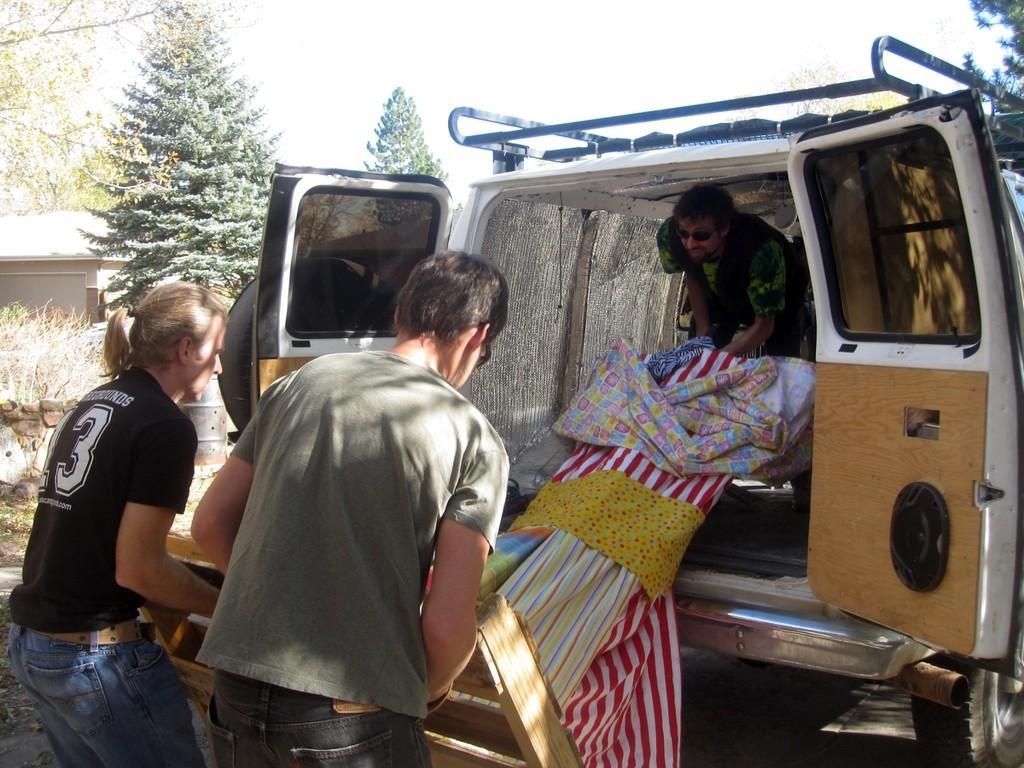Could you give a brief overview of what you see in this image? There are 2 persons carrying cot,on the right there is a vehicle,in the vehicle a person is there and he is taking bed into the vehicle. On the left there are trees,building and we can see sky. 